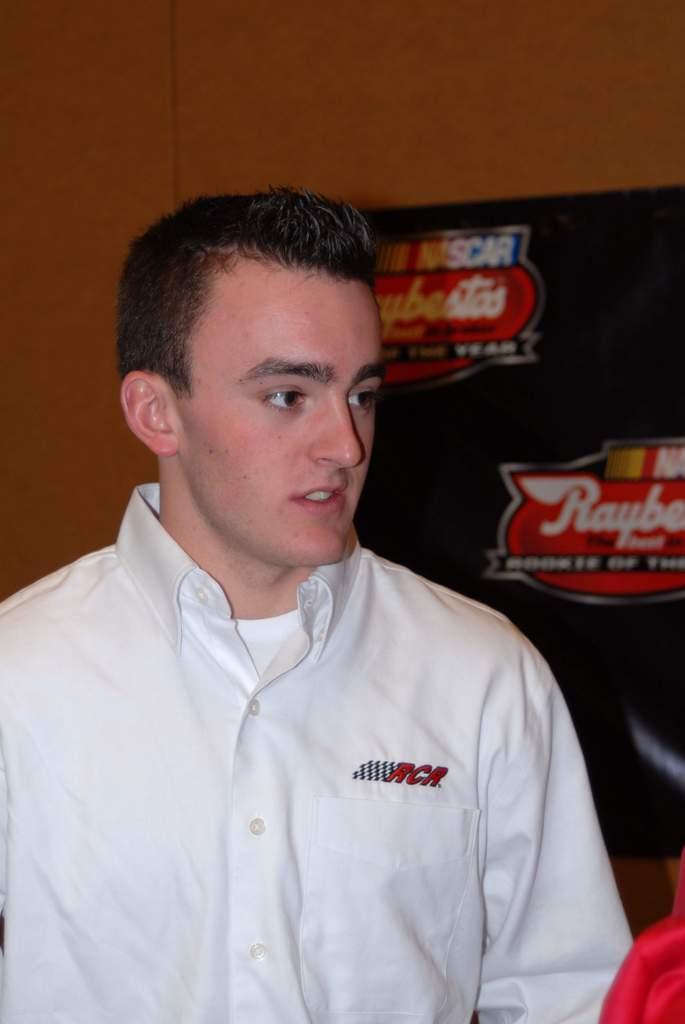What major american motorsport is behind the man?
Your answer should be very brief. Nascar. 